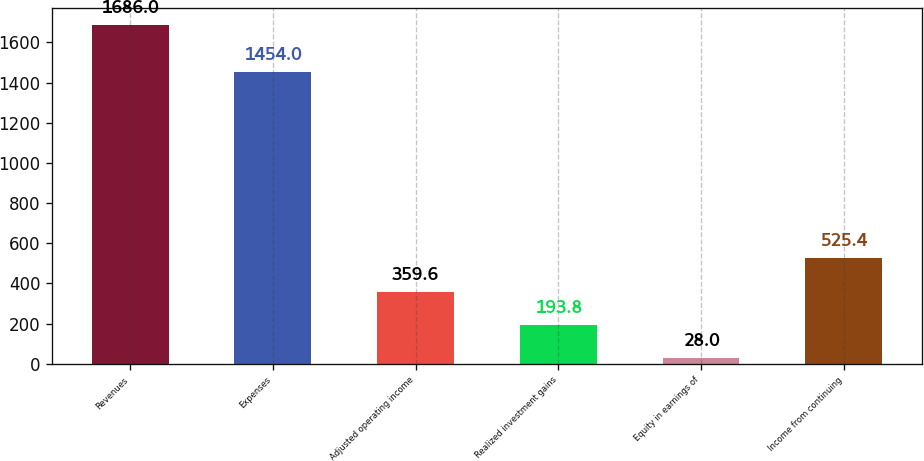Convert chart. <chart><loc_0><loc_0><loc_500><loc_500><bar_chart><fcel>Revenues<fcel>Expenses<fcel>Adjusted operating income<fcel>Realized investment gains<fcel>Equity in earnings of<fcel>Income from continuing<nl><fcel>1686<fcel>1454<fcel>359.6<fcel>193.8<fcel>28<fcel>525.4<nl></chart> 